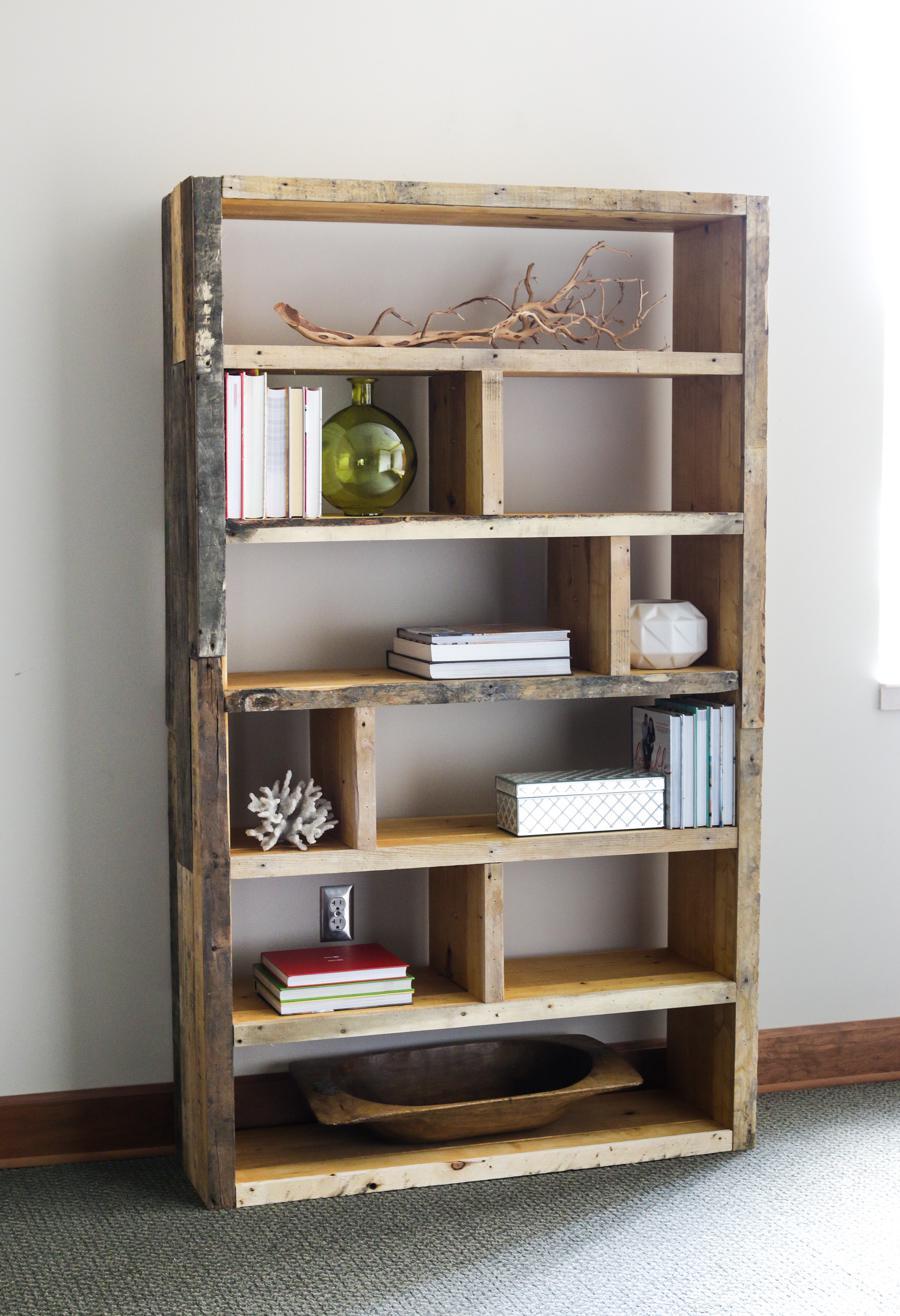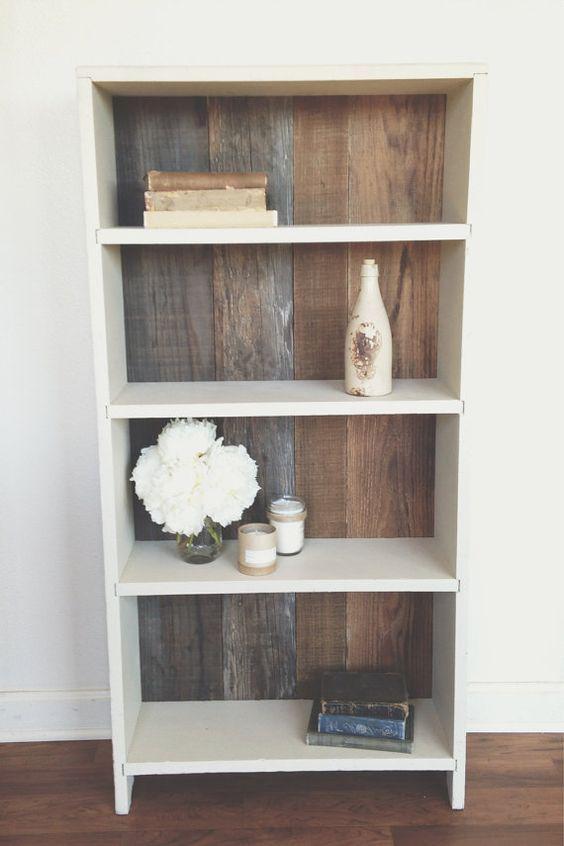The first image is the image on the left, the second image is the image on the right. Given the left and right images, does the statement "In one image, a shelf unit has six levels and an open back, while the shelf unit in the second image has fewer shelves and a solid enclosed back." hold true? Answer yes or no. Yes. The first image is the image on the left, the second image is the image on the right. For the images displayed, is the sentence "An image shows a white storage unit with at least one item on its flat top." factually correct? Answer yes or no. No. 